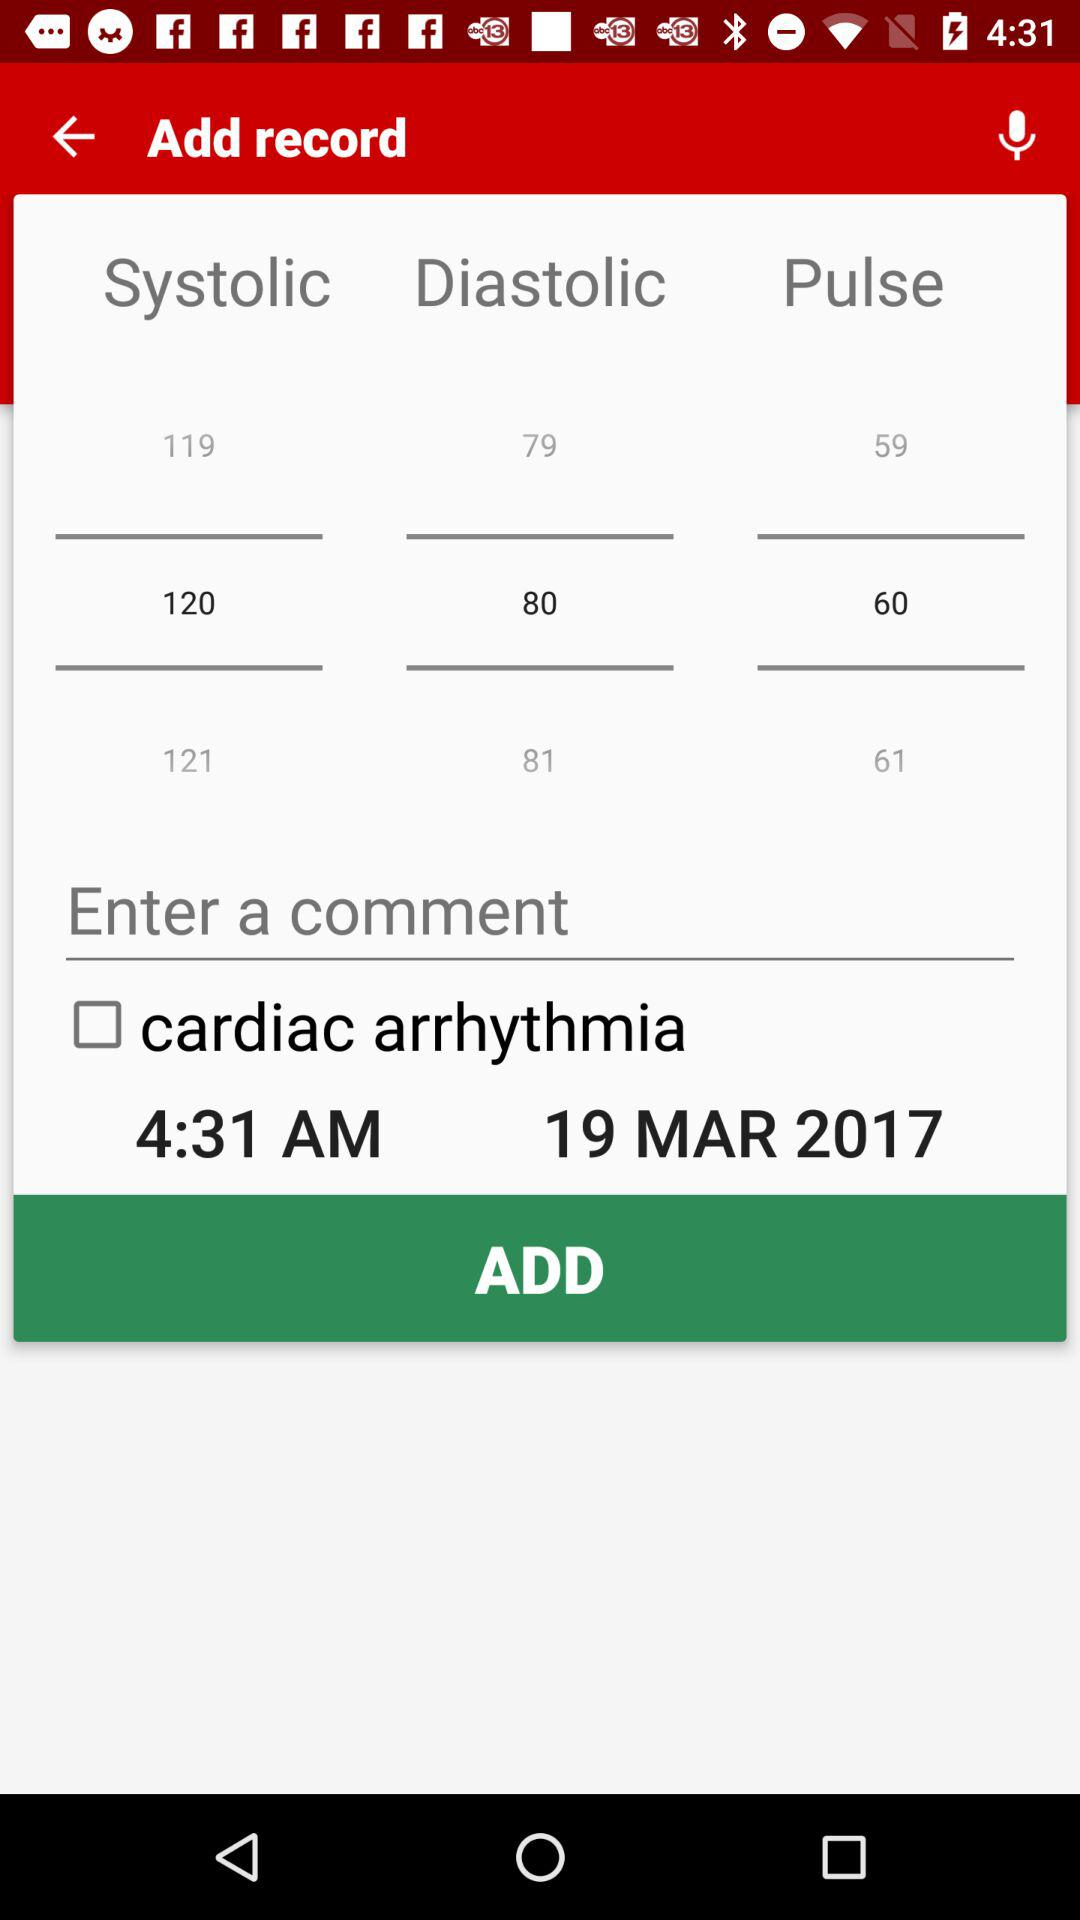What is the diastolic blood pressure? The diastolic blood pressure is 80. 